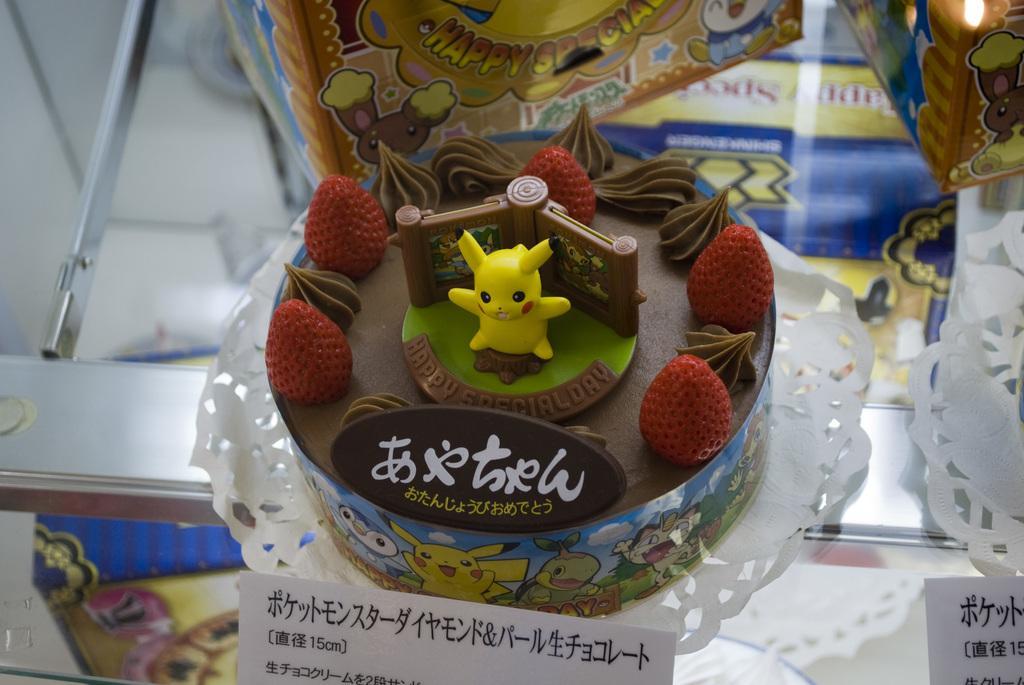Describe this image in one or two sentences. In this picture we can see the chocolate cake in the front with strawberries and yellow toy on the top. Behind there is a yellow color box. 